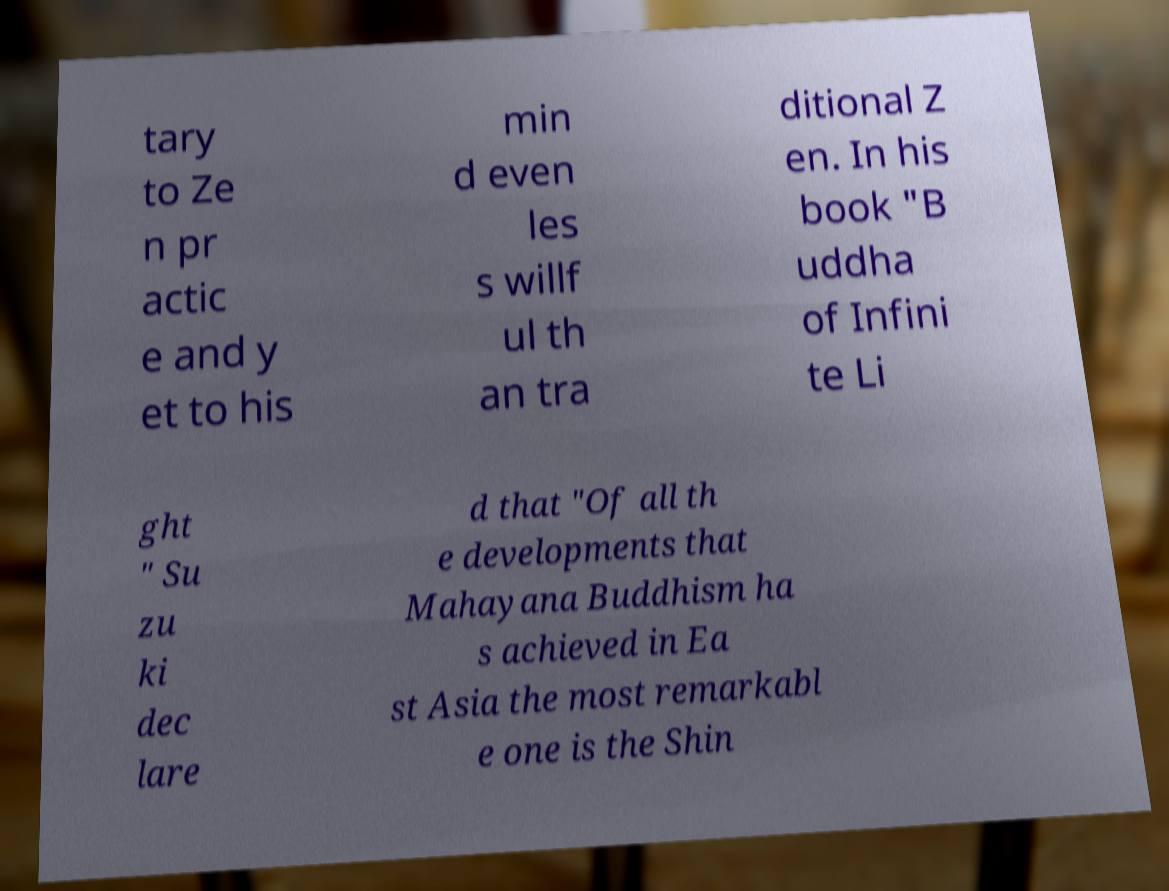Could you assist in decoding the text presented in this image and type it out clearly? tary to Ze n pr actic e and y et to his min d even les s willf ul th an tra ditional Z en. In his book "B uddha of Infini te Li ght " Su zu ki dec lare d that "Of all th e developments that Mahayana Buddhism ha s achieved in Ea st Asia the most remarkabl e one is the Shin 